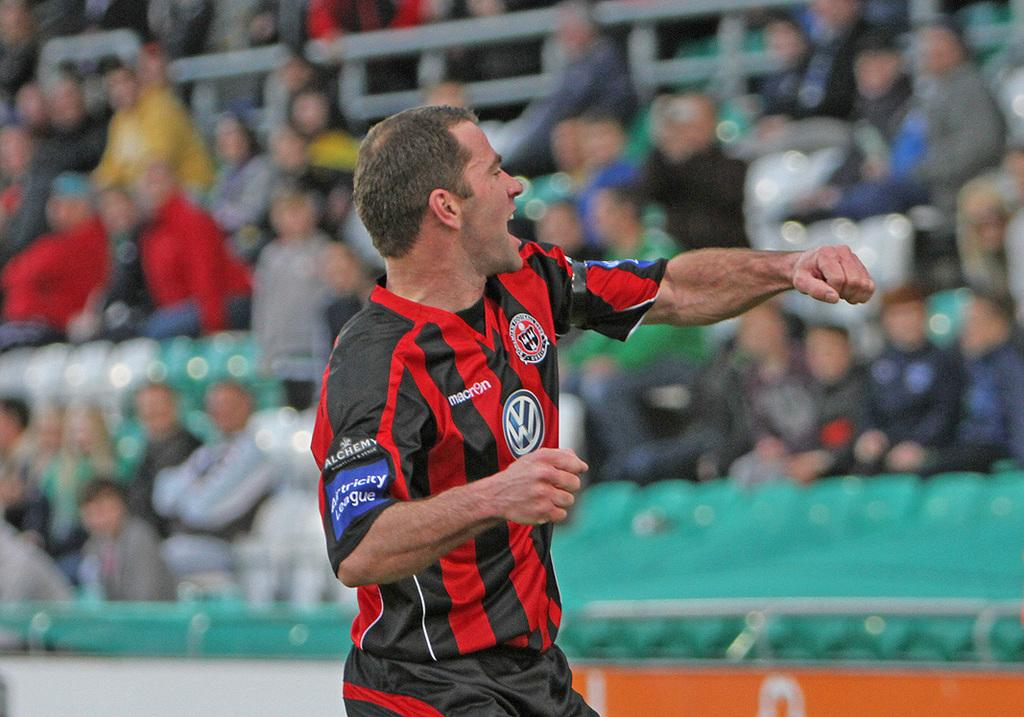<image>
Write a terse but informative summary of the picture. a man wearing a soccer jersey that says macri9n 